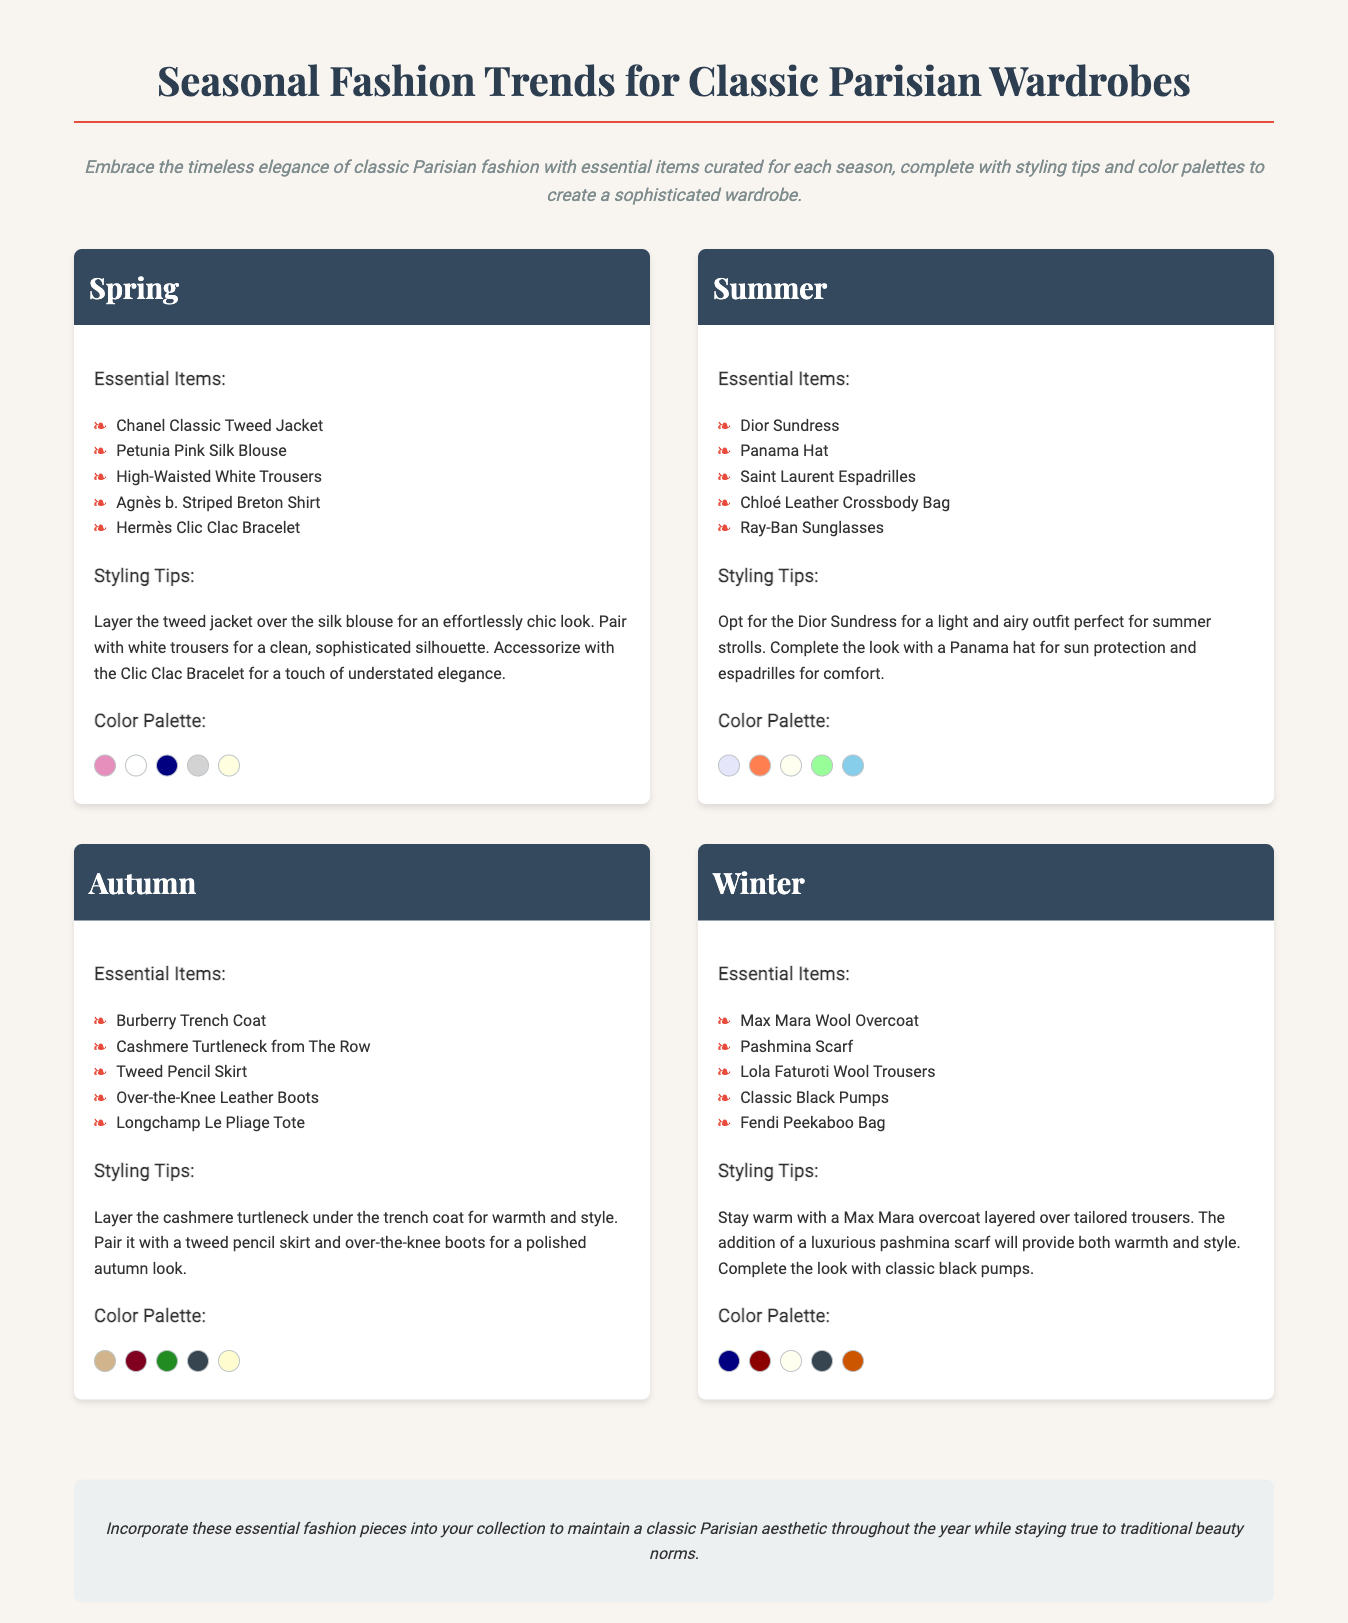What are the essential items for Spring? The essential items for Spring are listed under the Spring section in the document, which includes a Chanel Classic Tweed Jacket and a Petunia Pink Silk Blouse.
Answer: Chanel Classic Tweed Jacket, Petunia Pink Silk Blouse, High-Waisted White Trousers, Agnès b. Striped Breton Shirt, Hermès Clic Clac Bracelet What color palette is suggested for Summer? The color palette for Summer is provided in the Summer section, featuring colors like Light Lavender and Coral.
Answer: Light Lavender, Coral, Ivory, Mint Green, Sky Blue Which accessory is mentioned for Spring styling? The document lists accessories in the Spring styling tips, including the Hermès Clic Clac Bracelet.
Answer: Hermès Clic Clac Bracelet How many essential items are listed for Autumn? The Autumn section lists essential items, specifically five items mentioned in that category.
Answer: Five What is the main styling suggestion for Winter? The Winter styling tips suggest layering a Max Mara overcoat over tailored trousers for warmth and style.
Answer: Layered over tailored trousers Which item is highlighted as an essential for Summer? An essential item for Summer noted in the document is the Dior Sundress.
Answer: Dior Sundress What color is associated with the Winter color palette? One of the colors listed in the Winter color palette is Navy Blue.
Answer: Navy Blue What type of document is this? The document presents seasonal fashion trends specifically tailored for classic Parisian wardrobes.
Answer: Catalog 